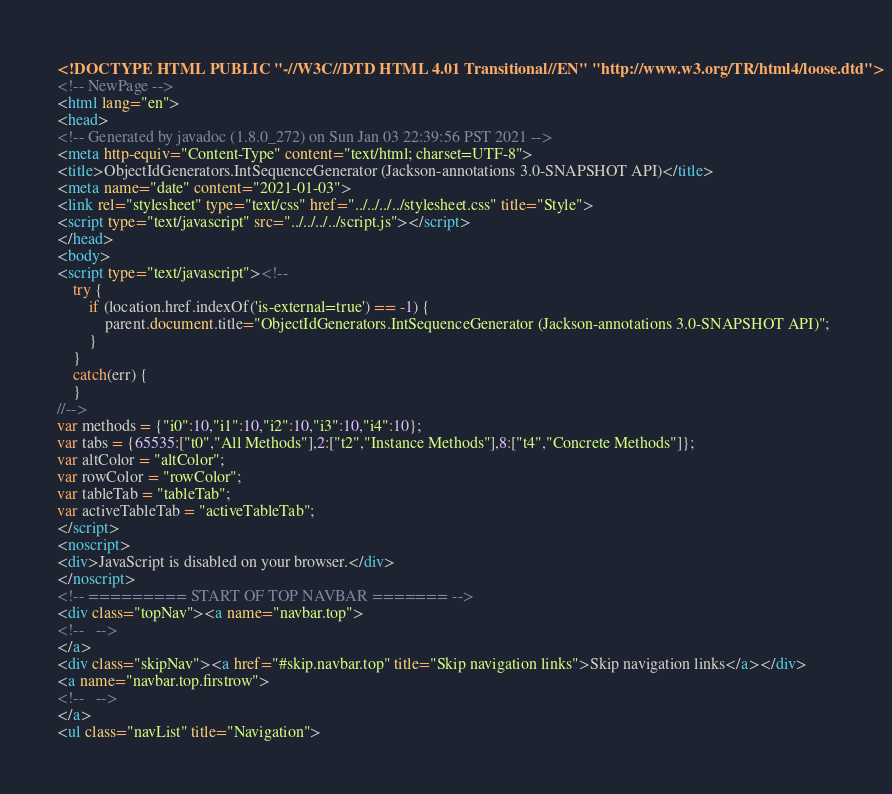<code> <loc_0><loc_0><loc_500><loc_500><_HTML_><!DOCTYPE HTML PUBLIC "-//W3C//DTD HTML 4.01 Transitional//EN" "http://www.w3.org/TR/html4/loose.dtd">
<!-- NewPage -->
<html lang="en">
<head>
<!-- Generated by javadoc (1.8.0_272) on Sun Jan 03 22:39:56 PST 2021 -->
<meta http-equiv="Content-Type" content="text/html; charset=UTF-8">
<title>ObjectIdGenerators.IntSequenceGenerator (Jackson-annotations 3.0-SNAPSHOT API)</title>
<meta name="date" content="2021-01-03">
<link rel="stylesheet" type="text/css" href="../../../../stylesheet.css" title="Style">
<script type="text/javascript" src="../../../../script.js"></script>
</head>
<body>
<script type="text/javascript"><!--
    try {
        if (location.href.indexOf('is-external=true') == -1) {
            parent.document.title="ObjectIdGenerators.IntSequenceGenerator (Jackson-annotations 3.0-SNAPSHOT API)";
        }
    }
    catch(err) {
    }
//-->
var methods = {"i0":10,"i1":10,"i2":10,"i3":10,"i4":10};
var tabs = {65535:["t0","All Methods"],2:["t2","Instance Methods"],8:["t4","Concrete Methods"]};
var altColor = "altColor";
var rowColor = "rowColor";
var tableTab = "tableTab";
var activeTableTab = "activeTableTab";
</script>
<noscript>
<div>JavaScript is disabled on your browser.</div>
</noscript>
<!-- ========= START OF TOP NAVBAR ======= -->
<div class="topNav"><a name="navbar.top">
<!--   -->
</a>
<div class="skipNav"><a href="#skip.navbar.top" title="Skip navigation links">Skip navigation links</a></div>
<a name="navbar.top.firstrow">
<!--   -->
</a>
<ul class="navList" title="Navigation"></code> 